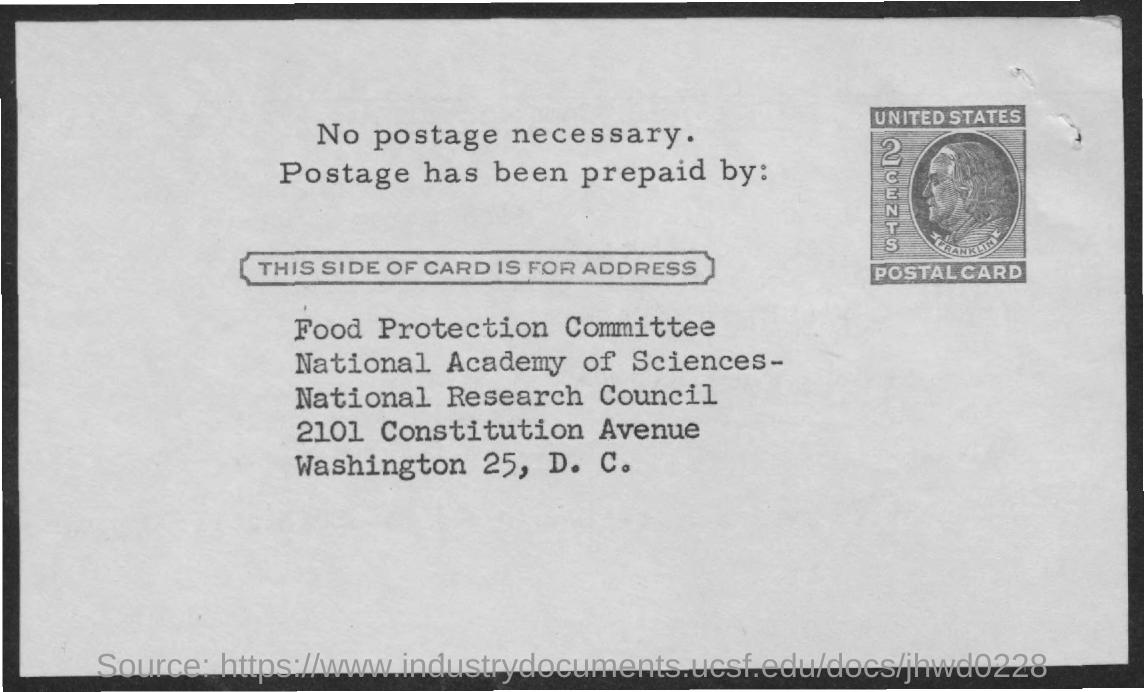What is the name of the committee mentioned in the address
Make the answer very short. Food Protection Committee. What is the cost of postage ?
Your answer should be compact. 2 cents. 